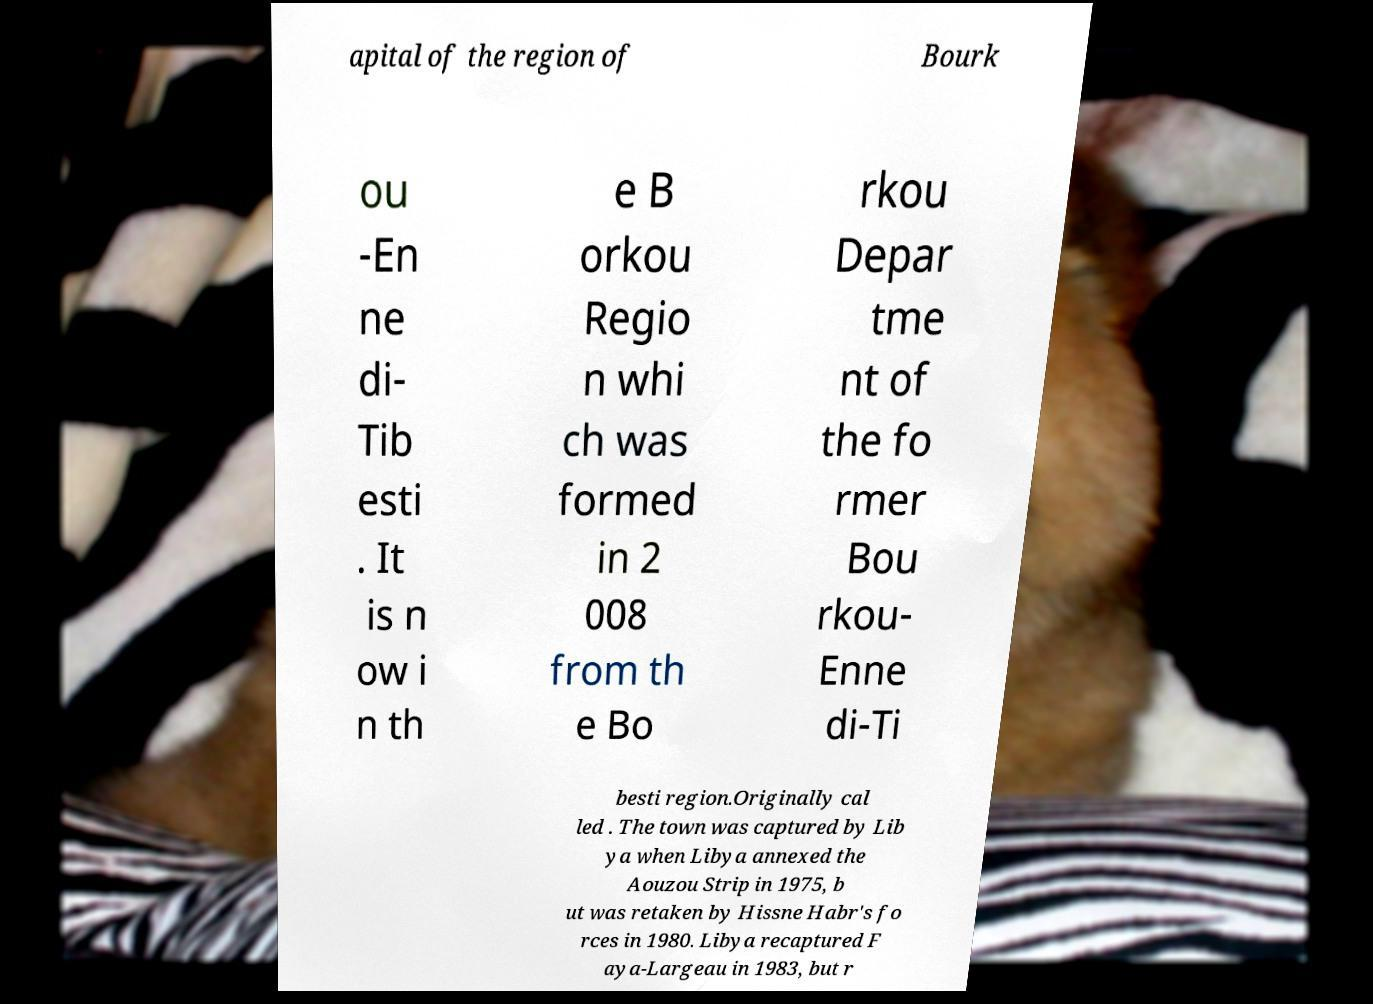For documentation purposes, I need the text within this image transcribed. Could you provide that? apital of the region of Bourk ou -En ne di- Tib esti . It is n ow i n th e B orkou Regio n whi ch was formed in 2 008 from th e Bo rkou Depar tme nt of the fo rmer Bou rkou- Enne di-Ti besti region.Originally cal led . The town was captured by Lib ya when Libya annexed the Aouzou Strip in 1975, b ut was retaken by Hissne Habr's fo rces in 1980. Libya recaptured F aya-Largeau in 1983, but r 